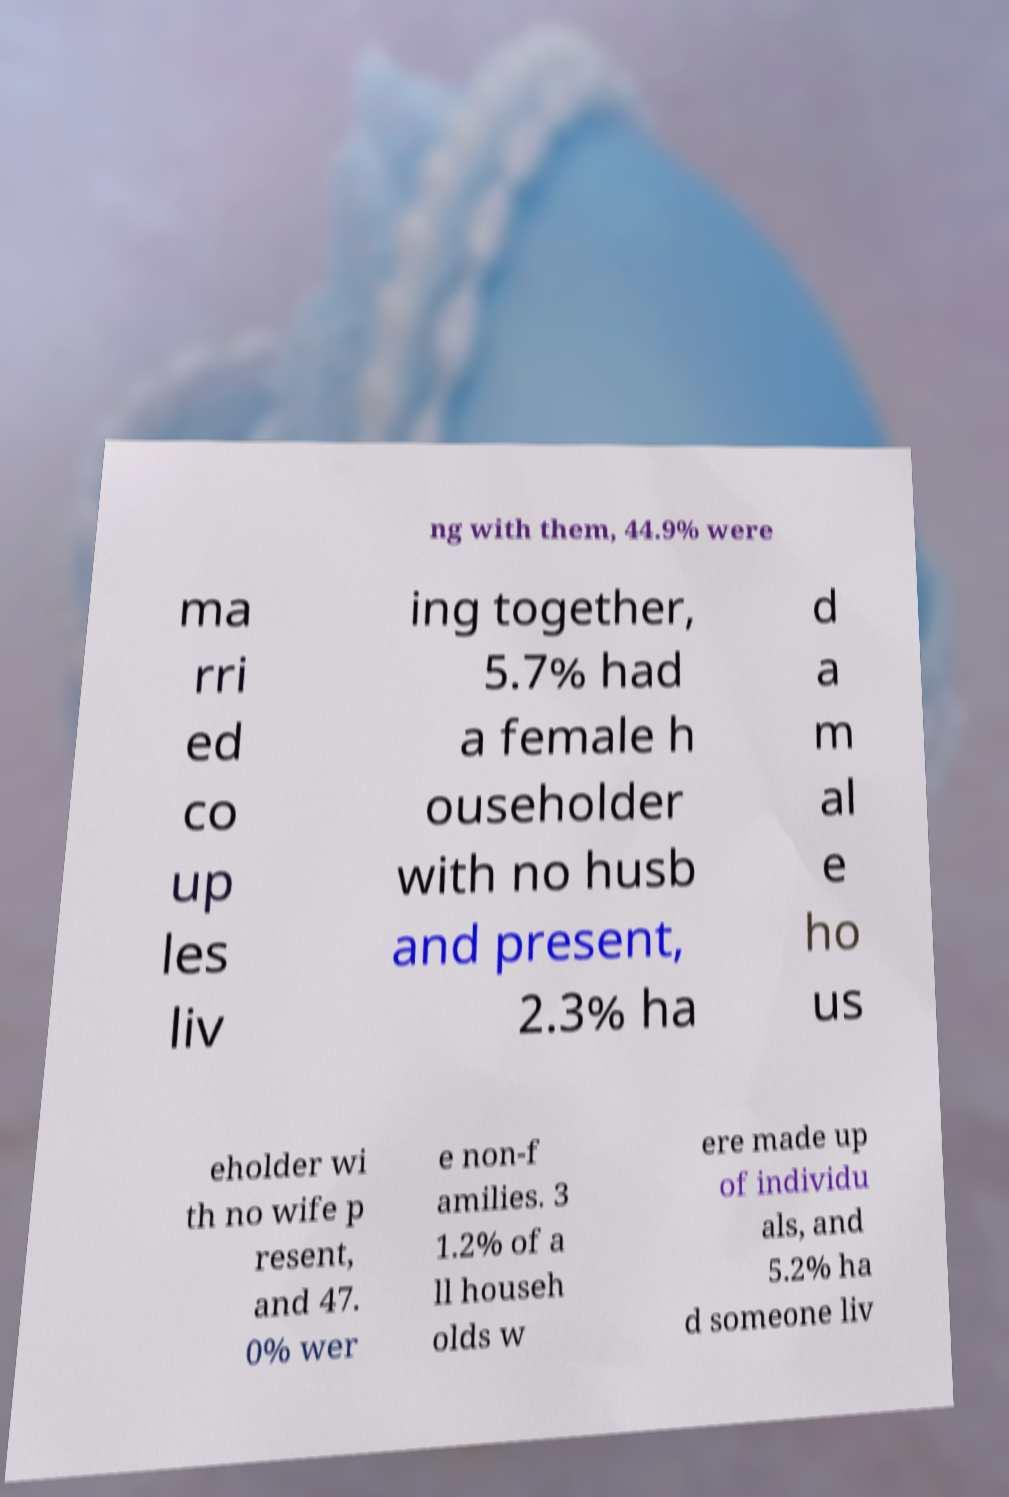Can you accurately transcribe the text from the provided image for me? ng with them, 44.9% were ma rri ed co up les liv ing together, 5.7% had a female h ouseholder with no husb and present, 2.3% ha d a m al e ho us eholder wi th no wife p resent, and 47. 0% wer e non-f amilies. 3 1.2% of a ll househ olds w ere made up of individu als, and 5.2% ha d someone liv 